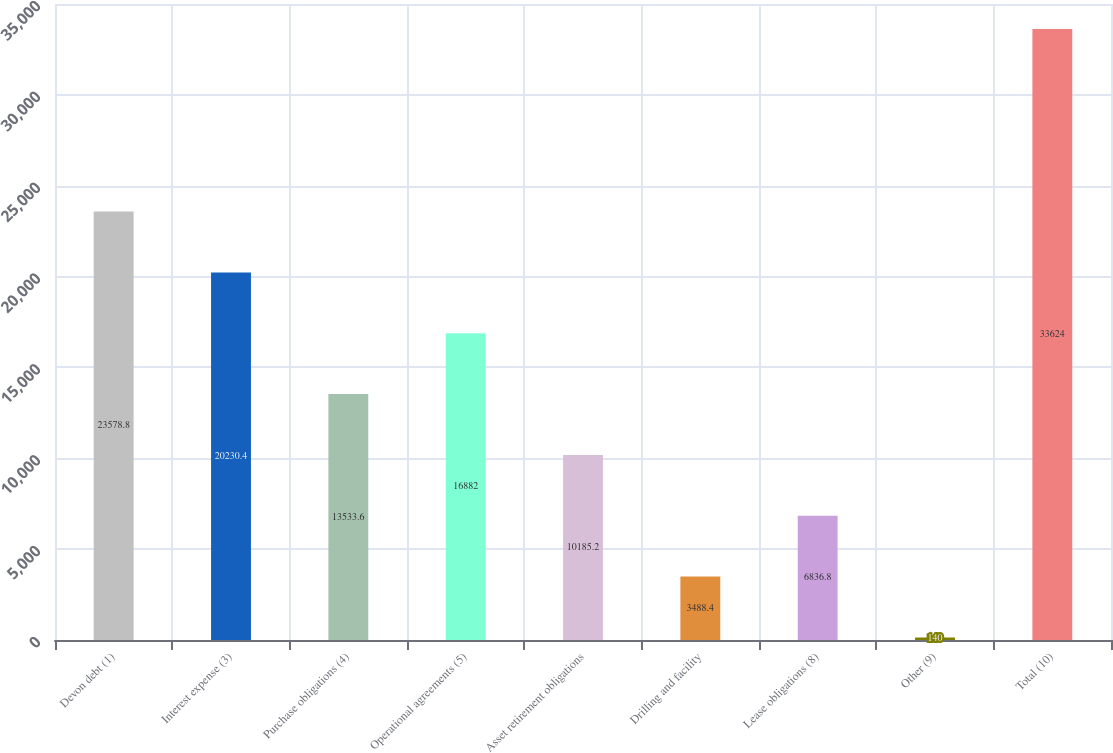Convert chart. <chart><loc_0><loc_0><loc_500><loc_500><bar_chart><fcel>Devon debt (1)<fcel>Interest expense (3)<fcel>Purchase obligations (4)<fcel>Operational agreements (5)<fcel>Asset retirement obligations<fcel>Drilling and facility<fcel>Lease obligations (8)<fcel>Other (9)<fcel>Total (10)<nl><fcel>23578.8<fcel>20230.4<fcel>13533.6<fcel>16882<fcel>10185.2<fcel>3488.4<fcel>6836.8<fcel>140<fcel>33624<nl></chart> 